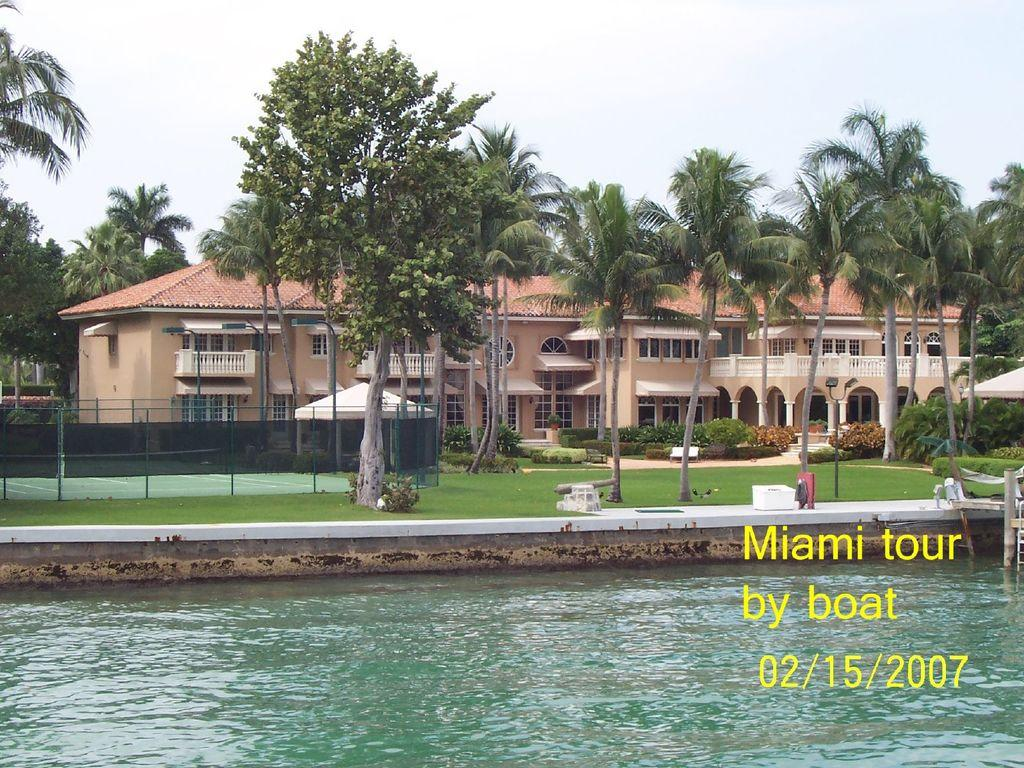What is at the bottom of the image? There is water at the bottom of the image. What can be seen in the middle of the image? Trees, plants, fencing, and a building are visible in the middle of the image. What is the condition of the sky in the image? There are clouds in the sky at the top of the image. Can you see the tail of the animal in the image? There is no animal present in the image, so there is no tail to be seen. What type of sack is being used to carry the plants in the image? There is no sack present in the image; the plants are growing in the ground. 